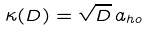<formula> <loc_0><loc_0><loc_500><loc_500>\kappa ( D ) = \sqrt { D } \, a _ { h o }</formula> 